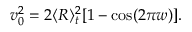<formula> <loc_0><loc_0><loc_500><loc_500>\begin{array} { r } { v _ { 0 } ^ { 2 } = 2 \langle R \rangle _ { t } ^ { 2 } [ 1 - \cos ( 2 \pi w ) ] . } \end{array}</formula> 